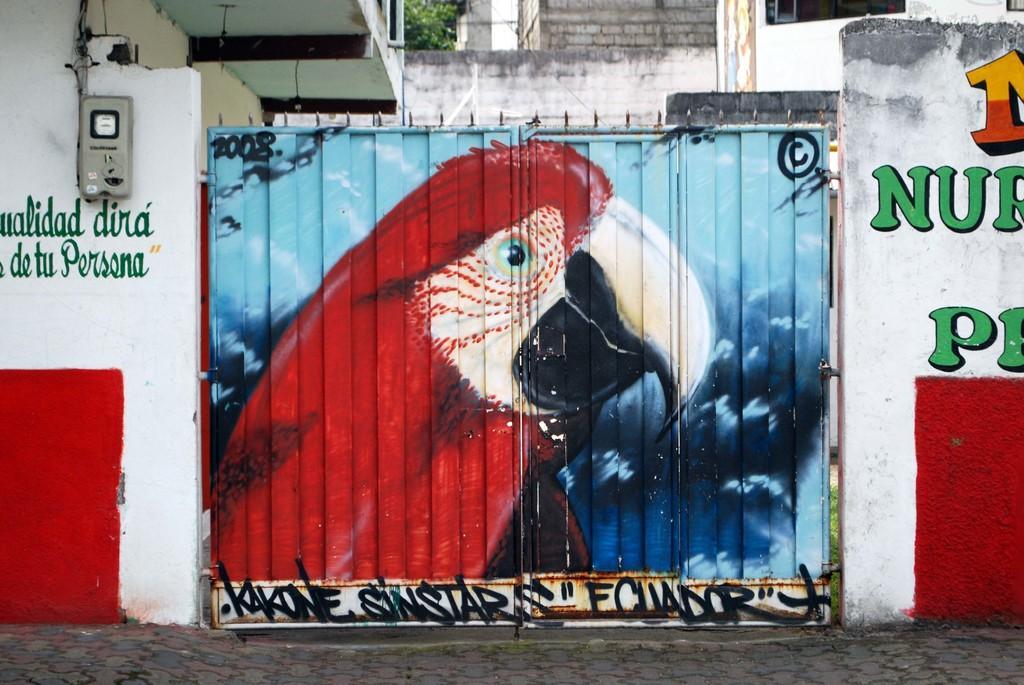Can you describe this image briefly? In this image we can see a gate painted with a bird and some text written. At the bottom of the image there is the floor. On the right side of the image there is a wall with some painting. On the left side of the image there is a wall with some painting and an electricity meter. In the background of the image there are some buildings, walls, tree and other objects. 